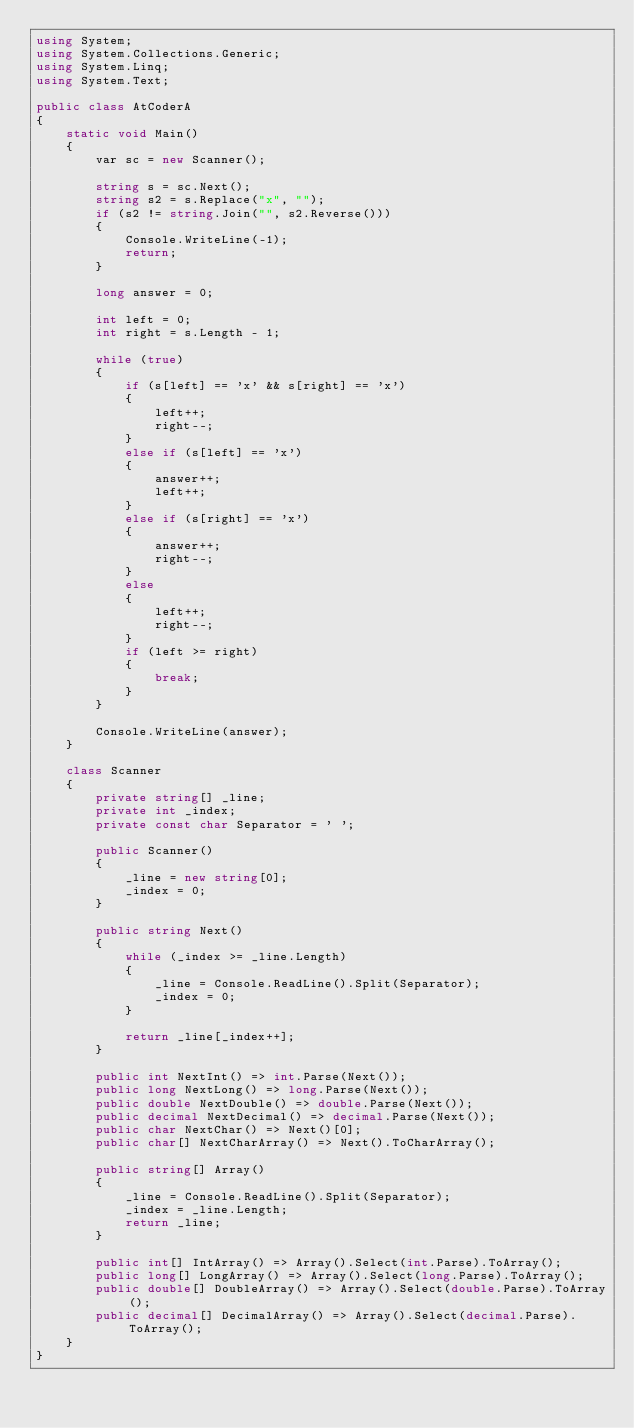Convert code to text. <code><loc_0><loc_0><loc_500><loc_500><_C#_>using System;
using System.Collections.Generic;
using System.Linq;
using System.Text;

public class AtCoderA
{
    static void Main()
    {
        var sc = new Scanner();

        string s = sc.Next();
        string s2 = s.Replace("x", "");
        if (s2 != string.Join("", s2.Reverse()))
        {
            Console.WriteLine(-1);
            return;
        }

        long answer = 0;

        int left = 0;
        int right = s.Length - 1;

        while (true)
        {
            if (s[left] == 'x' && s[right] == 'x')
            {
                left++;
                right--;
            }
            else if (s[left] == 'x')
            {
                answer++;
                left++;
            }
            else if (s[right] == 'x')
            {
                answer++;
                right--;
            }
            else
            {
                left++;
                right--;
            }
            if (left >= right)
            {
                break;
            }
        }

        Console.WriteLine(answer);
    }

    class Scanner
    {
        private string[] _line;
        private int _index;
        private const char Separator = ' ';

        public Scanner()
        {
            _line = new string[0];
            _index = 0;
        }

        public string Next()
        {
            while (_index >= _line.Length)
            {
                _line = Console.ReadLine().Split(Separator);
                _index = 0;
            }

            return _line[_index++];
        }

        public int NextInt() => int.Parse(Next());
        public long NextLong() => long.Parse(Next());
        public double NextDouble() => double.Parse(Next());
        public decimal NextDecimal() => decimal.Parse(Next());
        public char NextChar() => Next()[0];
        public char[] NextCharArray() => Next().ToCharArray();

        public string[] Array()
        {
            _line = Console.ReadLine().Split(Separator);
            _index = _line.Length;
            return _line;
        }

        public int[] IntArray() => Array().Select(int.Parse).ToArray();
        public long[] LongArray() => Array().Select(long.Parse).ToArray();
        public double[] DoubleArray() => Array().Select(double.Parse).ToArray();
        public decimal[] DecimalArray() => Array().Select(decimal.Parse).ToArray();
    }
}
</code> 